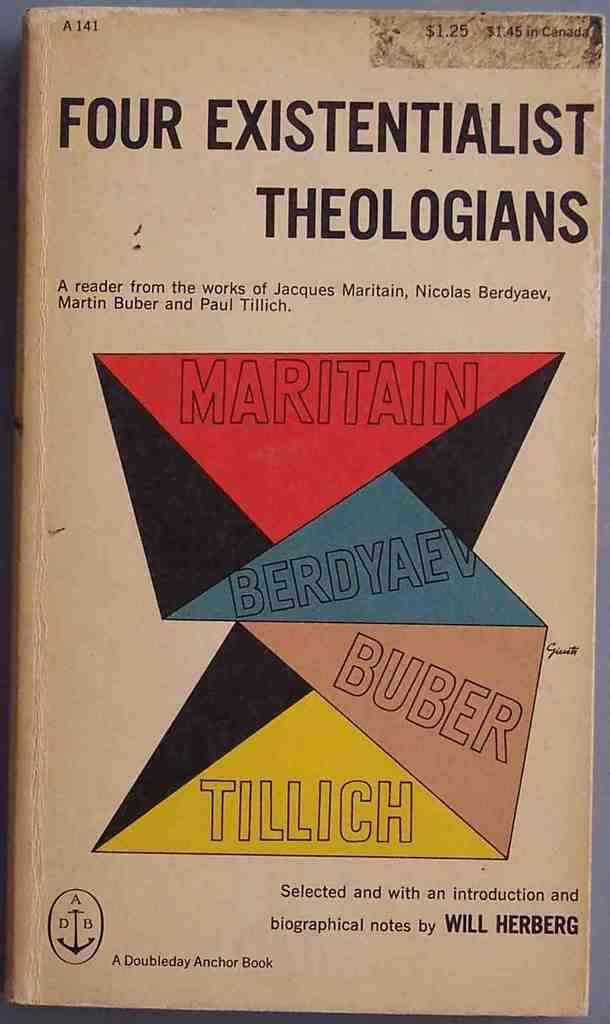Provide a one-sentence caption for the provided image. A book of four existentialist Theologians published by A Doubleday Anchor book. 